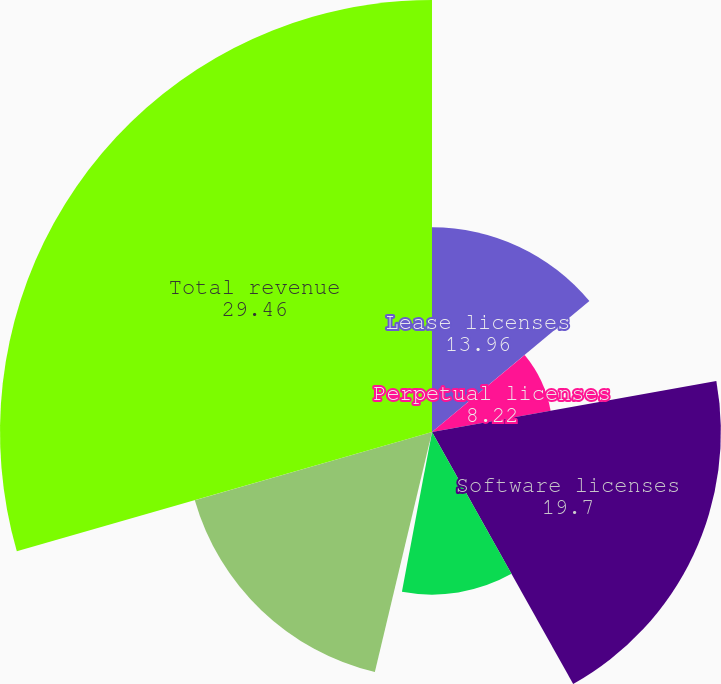Convert chart. <chart><loc_0><loc_0><loc_500><loc_500><pie_chart><fcel>Lease licenses<fcel>Perpetual licenses<fcel>Software licenses<fcel>Maintenance<fcel>Service<fcel>Maintenance and service<fcel>Total revenue<nl><fcel>13.96%<fcel>8.22%<fcel>19.7%<fcel>11.09%<fcel>0.76%<fcel>16.83%<fcel>29.46%<nl></chart> 